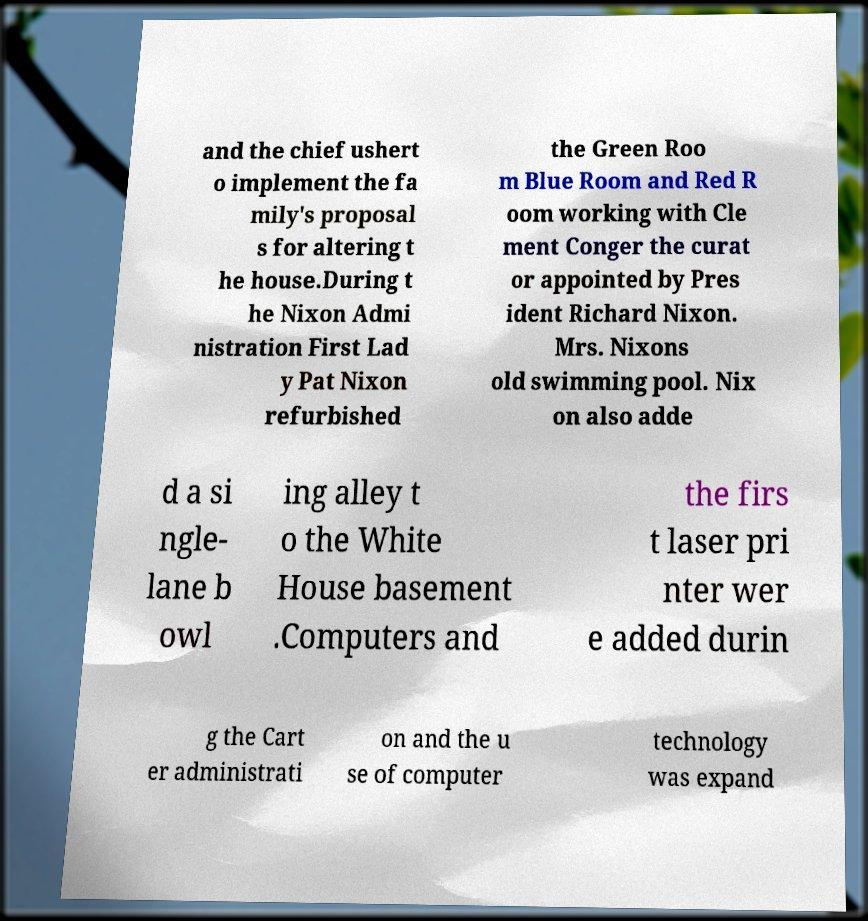Can you read and provide the text displayed in the image?This photo seems to have some interesting text. Can you extract and type it out for me? and the chief ushert o implement the fa mily's proposal s for altering t he house.During t he Nixon Admi nistration First Lad y Pat Nixon refurbished the Green Roo m Blue Room and Red R oom working with Cle ment Conger the curat or appointed by Pres ident Richard Nixon. Mrs. Nixons old swimming pool. Nix on also adde d a si ngle- lane b owl ing alley t o the White House basement .Computers and the firs t laser pri nter wer e added durin g the Cart er administrati on and the u se of computer technology was expand 